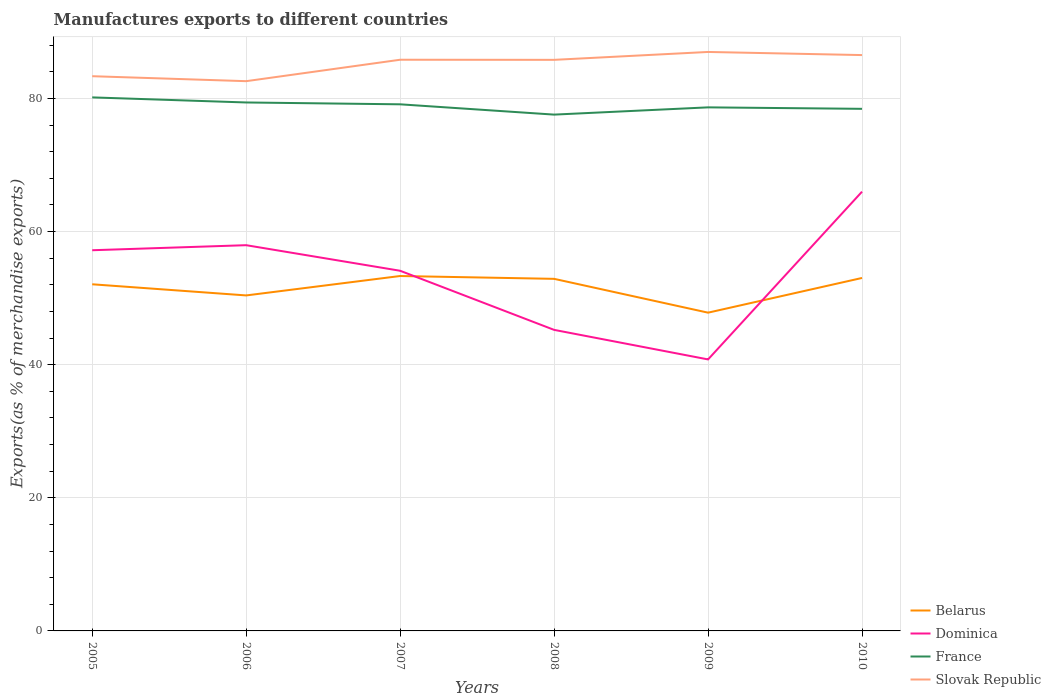How many different coloured lines are there?
Ensure brevity in your answer.  4. Does the line corresponding to Slovak Republic intersect with the line corresponding to Dominica?
Give a very brief answer. No. Across all years, what is the maximum percentage of exports to different countries in France?
Your response must be concise. 77.57. What is the total percentage of exports to different countries in Slovak Republic in the graph?
Your response must be concise. -3.22. What is the difference between the highest and the second highest percentage of exports to different countries in Slovak Republic?
Make the answer very short. 4.39. What is the difference between the highest and the lowest percentage of exports to different countries in Dominica?
Provide a short and direct response. 4. Is the percentage of exports to different countries in Dominica strictly greater than the percentage of exports to different countries in Belarus over the years?
Make the answer very short. No. How many lines are there?
Ensure brevity in your answer.  4. What is the difference between two consecutive major ticks on the Y-axis?
Keep it short and to the point. 20. How many legend labels are there?
Offer a terse response. 4. How are the legend labels stacked?
Your answer should be compact. Vertical. What is the title of the graph?
Make the answer very short. Manufactures exports to different countries. What is the label or title of the Y-axis?
Provide a succinct answer. Exports(as % of merchandise exports). What is the Exports(as % of merchandise exports) of Belarus in 2005?
Provide a succinct answer. 52.08. What is the Exports(as % of merchandise exports) of Dominica in 2005?
Offer a terse response. 57.19. What is the Exports(as % of merchandise exports) of France in 2005?
Provide a short and direct response. 80.15. What is the Exports(as % of merchandise exports) of Slovak Republic in 2005?
Offer a terse response. 83.34. What is the Exports(as % of merchandise exports) of Belarus in 2006?
Your response must be concise. 50.4. What is the Exports(as % of merchandise exports) of Dominica in 2006?
Provide a short and direct response. 57.95. What is the Exports(as % of merchandise exports) of France in 2006?
Keep it short and to the point. 79.39. What is the Exports(as % of merchandise exports) of Slovak Republic in 2006?
Your answer should be very brief. 82.59. What is the Exports(as % of merchandise exports) of Belarus in 2007?
Offer a terse response. 53.32. What is the Exports(as % of merchandise exports) in Dominica in 2007?
Your answer should be compact. 54.11. What is the Exports(as % of merchandise exports) in France in 2007?
Ensure brevity in your answer.  79.11. What is the Exports(as % of merchandise exports) of Slovak Republic in 2007?
Your answer should be very brief. 85.81. What is the Exports(as % of merchandise exports) of Belarus in 2008?
Provide a succinct answer. 52.89. What is the Exports(as % of merchandise exports) in Dominica in 2008?
Provide a short and direct response. 45.23. What is the Exports(as % of merchandise exports) of France in 2008?
Ensure brevity in your answer.  77.57. What is the Exports(as % of merchandise exports) of Slovak Republic in 2008?
Your answer should be very brief. 85.79. What is the Exports(as % of merchandise exports) of Belarus in 2009?
Make the answer very short. 47.81. What is the Exports(as % of merchandise exports) in Dominica in 2009?
Offer a very short reply. 40.79. What is the Exports(as % of merchandise exports) of France in 2009?
Keep it short and to the point. 78.66. What is the Exports(as % of merchandise exports) in Slovak Republic in 2009?
Offer a very short reply. 86.98. What is the Exports(as % of merchandise exports) in Belarus in 2010?
Your answer should be very brief. 53.03. What is the Exports(as % of merchandise exports) in Dominica in 2010?
Give a very brief answer. 65.99. What is the Exports(as % of merchandise exports) of France in 2010?
Provide a succinct answer. 78.44. What is the Exports(as % of merchandise exports) of Slovak Republic in 2010?
Offer a very short reply. 86.51. Across all years, what is the maximum Exports(as % of merchandise exports) of Belarus?
Give a very brief answer. 53.32. Across all years, what is the maximum Exports(as % of merchandise exports) of Dominica?
Give a very brief answer. 65.99. Across all years, what is the maximum Exports(as % of merchandise exports) in France?
Make the answer very short. 80.15. Across all years, what is the maximum Exports(as % of merchandise exports) of Slovak Republic?
Ensure brevity in your answer.  86.98. Across all years, what is the minimum Exports(as % of merchandise exports) of Belarus?
Offer a terse response. 47.81. Across all years, what is the minimum Exports(as % of merchandise exports) of Dominica?
Provide a succinct answer. 40.79. Across all years, what is the minimum Exports(as % of merchandise exports) in France?
Provide a short and direct response. 77.57. Across all years, what is the minimum Exports(as % of merchandise exports) in Slovak Republic?
Keep it short and to the point. 82.59. What is the total Exports(as % of merchandise exports) of Belarus in the graph?
Your answer should be compact. 309.53. What is the total Exports(as % of merchandise exports) in Dominica in the graph?
Make the answer very short. 321.25. What is the total Exports(as % of merchandise exports) in France in the graph?
Your response must be concise. 473.32. What is the total Exports(as % of merchandise exports) of Slovak Republic in the graph?
Your response must be concise. 511.03. What is the difference between the Exports(as % of merchandise exports) in Belarus in 2005 and that in 2006?
Ensure brevity in your answer.  1.67. What is the difference between the Exports(as % of merchandise exports) of Dominica in 2005 and that in 2006?
Offer a very short reply. -0.76. What is the difference between the Exports(as % of merchandise exports) in France in 2005 and that in 2006?
Give a very brief answer. 0.76. What is the difference between the Exports(as % of merchandise exports) in Slovak Republic in 2005 and that in 2006?
Make the answer very short. 0.75. What is the difference between the Exports(as % of merchandise exports) in Belarus in 2005 and that in 2007?
Your answer should be compact. -1.24. What is the difference between the Exports(as % of merchandise exports) of Dominica in 2005 and that in 2007?
Make the answer very short. 3.08. What is the difference between the Exports(as % of merchandise exports) in France in 2005 and that in 2007?
Make the answer very short. 1.04. What is the difference between the Exports(as % of merchandise exports) in Slovak Republic in 2005 and that in 2007?
Provide a short and direct response. -2.47. What is the difference between the Exports(as % of merchandise exports) of Belarus in 2005 and that in 2008?
Offer a very short reply. -0.82. What is the difference between the Exports(as % of merchandise exports) in Dominica in 2005 and that in 2008?
Provide a short and direct response. 11.96. What is the difference between the Exports(as % of merchandise exports) in France in 2005 and that in 2008?
Give a very brief answer. 2.59. What is the difference between the Exports(as % of merchandise exports) in Slovak Republic in 2005 and that in 2008?
Provide a short and direct response. -2.46. What is the difference between the Exports(as % of merchandise exports) in Belarus in 2005 and that in 2009?
Provide a succinct answer. 4.26. What is the difference between the Exports(as % of merchandise exports) of Dominica in 2005 and that in 2009?
Your response must be concise. 16.4. What is the difference between the Exports(as % of merchandise exports) of France in 2005 and that in 2009?
Keep it short and to the point. 1.5. What is the difference between the Exports(as % of merchandise exports) in Slovak Republic in 2005 and that in 2009?
Your answer should be very brief. -3.64. What is the difference between the Exports(as % of merchandise exports) in Belarus in 2005 and that in 2010?
Provide a succinct answer. -0.95. What is the difference between the Exports(as % of merchandise exports) in Dominica in 2005 and that in 2010?
Make the answer very short. -8.8. What is the difference between the Exports(as % of merchandise exports) in France in 2005 and that in 2010?
Offer a very short reply. 1.72. What is the difference between the Exports(as % of merchandise exports) of Slovak Republic in 2005 and that in 2010?
Your answer should be very brief. -3.17. What is the difference between the Exports(as % of merchandise exports) of Belarus in 2006 and that in 2007?
Your response must be concise. -2.92. What is the difference between the Exports(as % of merchandise exports) of Dominica in 2006 and that in 2007?
Offer a terse response. 3.84. What is the difference between the Exports(as % of merchandise exports) in France in 2006 and that in 2007?
Ensure brevity in your answer.  0.28. What is the difference between the Exports(as % of merchandise exports) in Slovak Republic in 2006 and that in 2007?
Keep it short and to the point. -3.22. What is the difference between the Exports(as % of merchandise exports) of Belarus in 2006 and that in 2008?
Make the answer very short. -2.49. What is the difference between the Exports(as % of merchandise exports) of Dominica in 2006 and that in 2008?
Your answer should be very brief. 12.72. What is the difference between the Exports(as % of merchandise exports) of France in 2006 and that in 2008?
Your response must be concise. 1.82. What is the difference between the Exports(as % of merchandise exports) in Slovak Republic in 2006 and that in 2008?
Give a very brief answer. -3.2. What is the difference between the Exports(as % of merchandise exports) in Belarus in 2006 and that in 2009?
Keep it short and to the point. 2.59. What is the difference between the Exports(as % of merchandise exports) of Dominica in 2006 and that in 2009?
Provide a short and direct response. 17.16. What is the difference between the Exports(as % of merchandise exports) in France in 2006 and that in 2009?
Give a very brief answer. 0.73. What is the difference between the Exports(as % of merchandise exports) in Slovak Republic in 2006 and that in 2009?
Offer a terse response. -4.39. What is the difference between the Exports(as % of merchandise exports) in Belarus in 2006 and that in 2010?
Your response must be concise. -2.62. What is the difference between the Exports(as % of merchandise exports) of Dominica in 2006 and that in 2010?
Offer a very short reply. -8.04. What is the difference between the Exports(as % of merchandise exports) in France in 2006 and that in 2010?
Ensure brevity in your answer.  0.96. What is the difference between the Exports(as % of merchandise exports) of Slovak Republic in 2006 and that in 2010?
Give a very brief answer. -3.92. What is the difference between the Exports(as % of merchandise exports) of Belarus in 2007 and that in 2008?
Your answer should be very brief. 0.43. What is the difference between the Exports(as % of merchandise exports) of Dominica in 2007 and that in 2008?
Offer a terse response. 8.88. What is the difference between the Exports(as % of merchandise exports) in France in 2007 and that in 2008?
Provide a succinct answer. 1.55. What is the difference between the Exports(as % of merchandise exports) in Slovak Republic in 2007 and that in 2008?
Provide a short and direct response. 0.02. What is the difference between the Exports(as % of merchandise exports) of Belarus in 2007 and that in 2009?
Your answer should be very brief. 5.51. What is the difference between the Exports(as % of merchandise exports) in Dominica in 2007 and that in 2009?
Provide a succinct answer. 13.32. What is the difference between the Exports(as % of merchandise exports) in France in 2007 and that in 2009?
Give a very brief answer. 0.46. What is the difference between the Exports(as % of merchandise exports) in Slovak Republic in 2007 and that in 2009?
Your response must be concise. -1.17. What is the difference between the Exports(as % of merchandise exports) in Belarus in 2007 and that in 2010?
Your response must be concise. 0.29. What is the difference between the Exports(as % of merchandise exports) of Dominica in 2007 and that in 2010?
Provide a succinct answer. -11.88. What is the difference between the Exports(as % of merchandise exports) of France in 2007 and that in 2010?
Keep it short and to the point. 0.68. What is the difference between the Exports(as % of merchandise exports) of Slovak Republic in 2007 and that in 2010?
Ensure brevity in your answer.  -0.7. What is the difference between the Exports(as % of merchandise exports) of Belarus in 2008 and that in 2009?
Your response must be concise. 5.08. What is the difference between the Exports(as % of merchandise exports) of Dominica in 2008 and that in 2009?
Offer a terse response. 4.44. What is the difference between the Exports(as % of merchandise exports) in France in 2008 and that in 2009?
Your answer should be compact. -1.09. What is the difference between the Exports(as % of merchandise exports) of Slovak Republic in 2008 and that in 2009?
Your answer should be compact. -1.19. What is the difference between the Exports(as % of merchandise exports) in Belarus in 2008 and that in 2010?
Your answer should be very brief. -0.13. What is the difference between the Exports(as % of merchandise exports) in Dominica in 2008 and that in 2010?
Your answer should be compact. -20.76. What is the difference between the Exports(as % of merchandise exports) of France in 2008 and that in 2010?
Offer a very short reply. -0.87. What is the difference between the Exports(as % of merchandise exports) in Slovak Republic in 2008 and that in 2010?
Ensure brevity in your answer.  -0.72. What is the difference between the Exports(as % of merchandise exports) in Belarus in 2009 and that in 2010?
Make the answer very short. -5.21. What is the difference between the Exports(as % of merchandise exports) in Dominica in 2009 and that in 2010?
Give a very brief answer. -25.2. What is the difference between the Exports(as % of merchandise exports) of France in 2009 and that in 2010?
Your answer should be very brief. 0.22. What is the difference between the Exports(as % of merchandise exports) of Slovak Republic in 2009 and that in 2010?
Ensure brevity in your answer.  0.47. What is the difference between the Exports(as % of merchandise exports) of Belarus in 2005 and the Exports(as % of merchandise exports) of Dominica in 2006?
Provide a short and direct response. -5.87. What is the difference between the Exports(as % of merchandise exports) of Belarus in 2005 and the Exports(as % of merchandise exports) of France in 2006?
Your answer should be very brief. -27.31. What is the difference between the Exports(as % of merchandise exports) in Belarus in 2005 and the Exports(as % of merchandise exports) in Slovak Republic in 2006?
Provide a succinct answer. -30.51. What is the difference between the Exports(as % of merchandise exports) in Dominica in 2005 and the Exports(as % of merchandise exports) in France in 2006?
Provide a short and direct response. -22.2. What is the difference between the Exports(as % of merchandise exports) of Dominica in 2005 and the Exports(as % of merchandise exports) of Slovak Republic in 2006?
Provide a short and direct response. -25.4. What is the difference between the Exports(as % of merchandise exports) in France in 2005 and the Exports(as % of merchandise exports) in Slovak Republic in 2006?
Offer a very short reply. -2.44. What is the difference between the Exports(as % of merchandise exports) of Belarus in 2005 and the Exports(as % of merchandise exports) of Dominica in 2007?
Ensure brevity in your answer.  -2.03. What is the difference between the Exports(as % of merchandise exports) of Belarus in 2005 and the Exports(as % of merchandise exports) of France in 2007?
Offer a very short reply. -27.04. What is the difference between the Exports(as % of merchandise exports) in Belarus in 2005 and the Exports(as % of merchandise exports) in Slovak Republic in 2007?
Keep it short and to the point. -33.73. What is the difference between the Exports(as % of merchandise exports) in Dominica in 2005 and the Exports(as % of merchandise exports) in France in 2007?
Make the answer very short. -21.92. What is the difference between the Exports(as % of merchandise exports) of Dominica in 2005 and the Exports(as % of merchandise exports) of Slovak Republic in 2007?
Provide a succinct answer. -28.62. What is the difference between the Exports(as % of merchandise exports) in France in 2005 and the Exports(as % of merchandise exports) in Slovak Republic in 2007?
Your response must be concise. -5.66. What is the difference between the Exports(as % of merchandise exports) of Belarus in 2005 and the Exports(as % of merchandise exports) of Dominica in 2008?
Offer a very short reply. 6.85. What is the difference between the Exports(as % of merchandise exports) of Belarus in 2005 and the Exports(as % of merchandise exports) of France in 2008?
Offer a very short reply. -25.49. What is the difference between the Exports(as % of merchandise exports) of Belarus in 2005 and the Exports(as % of merchandise exports) of Slovak Republic in 2008?
Your answer should be compact. -33.72. What is the difference between the Exports(as % of merchandise exports) in Dominica in 2005 and the Exports(as % of merchandise exports) in France in 2008?
Your answer should be compact. -20.38. What is the difference between the Exports(as % of merchandise exports) of Dominica in 2005 and the Exports(as % of merchandise exports) of Slovak Republic in 2008?
Your response must be concise. -28.6. What is the difference between the Exports(as % of merchandise exports) of France in 2005 and the Exports(as % of merchandise exports) of Slovak Republic in 2008?
Give a very brief answer. -5.64. What is the difference between the Exports(as % of merchandise exports) in Belarus in 2005 and the Exports(as % of merchandise exports) in Dominica in 2009?
Keep it short and to the point. 11.29. What is the difference between the Exports(as % of merchandise exports) of Belarus in 2005 and the Exports(as % of merchandise exports) of France in 2009?
Offer a terse response. -26.58. What is the difference between the Exports(as % of merchandise exports) of Belarus in 2005 and the Exports(as % of merchandise exports) of Slovak Republic in 2009?
Your response must be concise. -34.9. What is the difference between the Exports(as % of merchandise exports) in Dominica in 2005 and the Exports(as % of merchandise exports) in France in 2009?
Ensure brevity in your answer.  -21.47. What is the difference between the Exports(as % of merchandise exports) of Dominica in 2005 and the Exports(as % of merchandise exports) of Slovak Republic in 2009?
Ensure brevity in your answer.  -29.79. What is the difference between the Exports(as % of merchandise exports) of France in 2005 and the Exports(as % of merchandise exports) of Slovak Republic in 2009?
Make the answer very short. -6.83. What is the difference between the Exports(as % of merchandise exports) in Belarus in 2005 and the Exports(as % of merchandise exports) in Dominica in 2010?
Give a very brief answer. -13.91. What is the difference between the Exports(as % of merchandise exports) of Belarus in 2005 and the Exports(as % of merchandise exports) of France in 2010?
Your answer should be very brief. -26.36. What is the difference between the Exports(as % of merchandise exports) of Belarus in 2005 and the Exports(as % of merchandise exports) of Slovak Republic in 2010?
Offer a terse response. -34.43. What is the difference between the Exports(as % of merchandise exports) in Dominica in 2005 and the Exports(as % of merchandise exports) in France in 2010?
Offer a terse response. -21.24. What is the difference between the Exports(as % of merchandise exports) in Dominica in 2005 and the Exports(as % of merchandise exports) in Slovak Republic in 2010?
Provide a succinct answer. -29.32. What is the difference between the Exports(as % of merchandise exports) in France in 2005 and the Exports(as % of merchandise exports) in Slovak Republic in 2010?
Keep it short and to the point. -6.36. What is the difference between the Exports(as % of merchandise exports) in Belarus in 2006 and the Exports(as % of merchandise exports) in Dominica in 2007?
Offer a very short reply. -3.7. What is the difference between the Exports(as % of merchandise exports) of Belarus in 2006 and the Exports(as % of merchandise exports) of France in 2007?
Your answer should be compact. -28.71. What is the difference between the Exports(as % of merchandise exports) of Belarus in 2006 and the Exports(as % of merchandise exports) of Slovak Republic in 2007?
Offer a very short reply. -35.41. What is the difference between the Exports(as % of merchandise exports) in Dominica in 2006 and the Exports(as % of merchandise exports) in France in 2007?
Offer a terse response. -21.16. What is the difference between the Exports(as % of merchandise exports) of Dominica in 2006 and the Exports(as % of merchandise exports) of Slovak Republic in 2007?
Keep it short and to the point. -27.86. What is the difference between the Exports(as % of merchandise exports) of France in 2006 and the Exports(as % of merchandise exports) of Slovak Republic in 2007?
Give a very brief answer. -6.42. What is the difference between the Exports(as % of merchandise exports) in Belarus in 2006 and the Exports(as % of merchandise exports) in Dominica in 2008?
Give a very brief answer. 5.17. What is the difference between the Exports(as % of merchandise exports) of Belarus in 2006 and the Exports(as % of merchandise exports) of France in 2008?
Keep it short and to the point. -27.16. What is the difference between the Exports(as % of merchandise exports) in Belarus in 2006 and the Exports(as % of merchandise exports) in Slovak Republic in 2008?
Your answer should be very brief. -35.39. What is the difference between the Exports(as % of merchandise exports) of Dominica in 2006 and the Exports(as % of merchandise exports) of France in 2008?
Provide a short and direct response. -19.62. What is the difference between the Exports(as % of merchandise exports) in Dominica in 2006 and the Exports(as % of merchandise exports) in Slovak Republic in 2008?
Make the answer very short. -27.84. What is the difference between the Exports(as % of merchandise exports) in France in 2006 and the Exports(as % of merchandise exports) in Slovak Republic in 2008?
Make the answer very short. -6.4. What is the difference between the Exports(as % of merchandise exports) of Belarus in 2006 and the Exports(as % of merchandise exports) of Dominica in 2009?
Ensure brevity in your answer.  9.61. What is the difference between the Exports(as % of merchandise exports) of Belarus in 2006 and the Exports(as % of merchandise exports) of France in 2009?
Offer a very short reply. -28.25. What is the difference between the Exports(as % of merchandise exports) in Belarus in 2006 and the Exports(as % of merchandise exports) in Slovak Republic in 2009?
Offer a terse response. -36.58. What is the difference between the Exports(as % of merchandise exports) of Dominica in 2006 and the Exports(as % of merchandise exports) of France in 2009?
Make the answer very short. -20.71. What is the difference between the Exports(as % of merchandise exports) in Dominica in 2006 and the Exports(as % of merchandise exports) in Slovak Republic in 2009?
Offer a terse response. -29.03. What is the difference between the Exports(as % of merchandise exports) in France in 2006 and the Exports(as % of merchandise exports) in Slovak Republic in 2009?
Your answer should be compact. -7.59. What is the difference between the Exports(as % of merchandise exports) of Belarus in 2006 and the Exports(as % of merchandise exports) of Dominica in 2010?
Provide a succinct answer. -15.59. What is the difference between the Exports(as % of merchandise exports) in Belarus in 2006 and the Exports(as % of merchandise exports) in France in 2010?
Provide a short and direct response. -28.03. What is the difference between the Exports(as % of merchandise exports) of Belarus in 2006 and the Exports(as % of merchandise exports) of Slovak Republic in 2010?
Offer a terse response. -36.11. What is the difference between the Exports(as % of merchandise exports) of Dominica in 2006 and the Exports(as % of merchandise exports) of France in 2010?
Your answer should be compact. -20.49. What is the difference between the Exports(as % of merchandise exports) in Dominica in 2006 and the Exports(as % of merchandise exports) in Slovak Republic in 2010?
Provide a succinct answer. -28.56. What is the difference between the Exports(as % of merchandise exports) of France in 2006 and the Exports(as % of merchandise exports) of Slovak Republic in 2010?
Provide a short and direct response. -7.12. What is the difference between the Exports(as % of merchandise exports) in Belarus in 2007 and the Exports(as % of merchandise exports) in Dominica in 2008?
Your answer should be compact. 8.09. What is the difference between the Exports(as % of merchandise exports) of Belarus in 2007 and the Exports(as % of merchandise exports) of France in 2008?
Provide a short and direct response. -24.25. What is the difference between the Exports(as % of merchandise exports) of Belarus in 2007 and the Exports(as % of merchandise exports) of Slovak Republic in 2008?
Your response must be concise. -32.47. What is the difference between the Exports(as % of merchandise exports) of Dominica in 2007 and the Exports(as % of merchandise exports) of France in 2008?
Offer a terse response. -23.46. What is the difference between the Exports(as % of merchandise exports) in Dominica in 2007 and the Exports(as % of merchandise exports) in Slovak Republic in 2008?
Give a very brief answer. -31.69. What is the difference between the Exports(as % of merchandise exports) of France in 2007 and the Exports(as % of merchandise exports) of Slovak Republic in 2008?
Provide a succinct answer. -6.68. What is the difference between the Exports(as % of merchandise exports) of Belarus in 2007 and the Exports(as % of merchandise exports) of Dominica in 2009?
Keep it short and to the point. 12.53. What is the difference between the Exports(as % of merchandise exports) in Belarus in 2007 and the Exports(as % of merchandise exports) in France in 2009?
Offer a very short reply. -25.34. What is the difference between the Exports(as % of merchandise exports) of Belarus in 2007 and the Exports(as % of merchandise exports) of Slovak Republic in 2009?
Your response must be concise. -33.66. What is the difference between the Exports(as % of merchandise exports) in Dominica in 2007 and the Exports(as % of merchandise exports) in France in 2009?
Give a very brief answer. -24.55. What is the difference between the Exports(as % of merchandise exports) in Dominica in 2007 and the Exports(as % of merchandise exports) in Slovak Republic in 2009?
Offer a terse response. -32.87. What is the difference between the Exports(as % of merchandise exports) in France in 2007 and the Exports(as % of merchandise exports) in Slovak Republic in 2009?
Your answer should be very brief. -7.87. What is the difference between the Exports(as % of merchandise exports) in Belarus in 2007 and the Exports(as % of merchandise exports) in Dominica in 2010?
Make the answer very short. -12.67. What is the difference between the Exports(as % of merchandise exports) of Belarus in 2007 and the Exports(as % of merchandise exports) of France in 2010?
Your response must be concise. -25.12. What is the difference between the Exports(as % of merchandise exports) in Belarus in 2007 and the Exports(as % of merchandise exports) in Slovak Republic in 2010?
Provide a succinct answer. -33.19. What is the difference between the Exports(as % of merchandise exports) in Dominica in 2007 and the Exports(as % of merchandise exports) in France in 2010?
Your response must be concise. -24.33. What is the difference between the Exports(as % of merchandise exports) of Dominica in 2007 and the Exports(as % of merchandise exports) of Slovak Republic in 2010?
Make the answer very short. -32.4. What is the difference between the Exports(as % of merchandise exports) in France in 2007 and the Exports(as % of merchandise exports) in Slovak Republic in 2010?
Your response must be concise. -7.4. What is the difference between the Exports(as % of merchandise exports) of Belarus in 2008 and the Exports(as % of merchandise exports) of Dominica in 2009?
Provide a short and direct response. 12.11. What is the difference between the Exports(as % of merchandise exports) in Belarus in 2008 and the Exports(as % of merchandise exports) in France in 2009?
Offer a very short reply. -25.76. What is the difference between the Exports(as % of merchandise exports) of Belarus in 2008 and the Exports(as % of merchandise exports) of Slovak Republic in 2009?
Ensure brevity in your answer.  -34.09. What is the difference between the Exports(as % of merchandise exports) in Dominica in 2008 and the Exports(as % of merchandise exports) in France in 2009?
Your answer should be very brief. -33.43. What is the difference between the Exports(as % of merchandise exports) in Dominica in 2008 and the Exports(as % of merchandise exports) in Slovak Republic in 2009?
Provide a short and direct response. -41.75. What is the difference between the Exports(as % of merchandise exports) in France in 2008 and the Exports(as % of merchandise exports) in Slovak Republic in 2009?
Provide a succinct answer. -9.41. What is the difference between the Exports(as % of merchandise exports) in Belarus in 2008 and the Exports(as % of merchandise exports) in Dominica in 2010?
Your answer should be very brief. -13.1. What is the difference between the Exports(as % of merchandise exports) in Belarus in 2008 and the Exports(as % of merchandise exports) in France in 2010?
Provide a short and direct response. -25.54. What is the difference between the Exports(as % of merchandise exports) of Belarus in 2008 and the Exports(as % of merchandise exports) of Slovak Republic in 2010?
Give a very brief answer. -33.62. What is the difference between the Exports(as % of merchandise exports) of Dominica in 2008 and the Exports(as % of merchandise exports) of France in 2010?
Provide a succinct answer. -33.21. What is the difference between the Exports(as % of merchandise exports) in Dominica in 2008 and the Exports(as % of merchandise exports) in Slovak Republic in 2010?
Provide a short and direct response. -41.28. What is the difference between the Exports(as % of merchandise exports) of France in 2008 and the Exports(as % of merchandise exports) of Slovak Republic in 2010?
Offer a very short reply. -8.94. What is the difference between the Exports(as % of merchandise exports) of Belarus in 2009 and the Exports(as % of merchandise exports) of Dominica in 2010?
Offer a very short reply. -18.18. What is the difference between the Exports(as % of merchandise exports) in Belarus in 2009 and the Exports(as % of merchandise exports) in France in 2010?
Keep it short and to the point. -30.62. What is the difference between the Exports(as % of merchandise exports) of Belarus in 2009 and the Exports(as % of merchandise exports) of Slovak Republic in 2010?
Give a very brief answer. -38.7. What is the difference between the Exports(as % of merchandise exports) of Dominica in 2009 and the Exports(as % of merchandise exports) of France in 2010?
Make the answer very short. -37.65. What is the difference between the Exports(as % of merchandise exports) in Dominica in 2009 and the Exports(as % of merchandise exports) in Slovak Republic in 2010?
Provide a short and direct response. -45.72. What is the difference between the Exports(as % of merchandise exports) of France in 2009 and the Exports(as % of merchandise exports) of Slovak Republic in 2010?
Provide a succinct answer. -7.85. What is the average Exports(as % of merchandise exports) in Belarus per year?
Your answer should be compact. 51.59. What is the average Exports(as % of merchandise exports) of Dominica per year?
Ensure brevity in your answer.  53.54. What is the average Exports(as % of merchandise exports) of France per year?
Offer a terse response. 78.89. What is the average Exports(as % of merchandise exports) in Slovak Republic per year?
Make the answer very short. 85.17. In the year 2005, what is the difference between the Exports(as % of merchandise exports) of Belarus and Exports(as % of merchandise exports) of Dominica?
Make the answer very short. -5.11. In the year 2005, what is the difference between the Exports(as % of merchandise exports) in Belarus and Exports(as % of merchandise exports) in France?
Your response must be concise. -28.08. In the year 2005, what is the difference between the Exports(as % of merchandise exports) of Belarus and Exports(as % of merchandise exports) of Slovak Republic?
Your answer should be compact. -31.26. In the year 2005, what is the difference between the Exports(as % of merchandise exports) of Dominica and Exports(as % of merchandise exports) of France?
Offer a terse response. -22.96. In the year 2005, what is the difference between the Exports(as % of merchandise exports) of Dominica and Exports(as % of merchandise exports) of Slovak Republic?
Give a very brief answer. -26.15. In the year 2005, what is the difference between the Exports(as % of merchandise exports) of France and Exports(as % of merchandise exports) of Slovak Republic?
Offer a terse response. -3.18. In the year 2006, what is the difference between the Exports(as % of merchandise exports) in Belarus and Exports(as % of merchandise exports) in Dominica?
Make the answer very short. -7.55. In the year 2006, what is the difference between the Exports(as % of merchandise exports) in Belarus and Exports(as % of merchandise exports) in France?
Keep it short and to the point. -28.99. In the year 2006, what is the difference between the Exports(as % of merchandise exports) in Belarus and Exports(as % of merchandise exports) in Slovak Republic?
Give a very brief answer. -32.19. In the year 2006, what is the difference between the Exports(as % of merchandise exports) of Dominica and Exports(as % of merchandise exports) of France?
Provide a succinct answer. -21.44. In the year 2006, what is the difference between the Exports(as % of merchandise exports) in Dominica and Exports(as % of merchandise exports) in Slovak Republic?
Provide a succinct answer. -24.64. In the year 2006, what is the difference between the Exports(as % of merchandise exports) of France and Exports(as % of merchandise exports) of Slovak Republic?
Give a very brief answer. -3.2. In the year 2007, what is the difference between the Exports(as % of merchandise exports) in Belarus and Exports(as % of merchandise exports) in Dominica?
Keep it short and to the point. -0.79. In the year 2007, what is the difference between the Exports(as % of merchandise exports) in Belarus and Exports(as % of merchandise exports) in France?
Make the answer very short. -25.79. In the year 2007, what is the difference between the Exports(as % of merchandise exports) in Belarus and Exports(as % of merchandise exports) in Slovak Republic?
Your answer should be very brief. -32.49. In the year 2007, what is the difference between the Exports(as % of merchandise exports) of Dominica and Exports(as % of merchandise exports) of France?
Make the answer very short. -25.01. In the year 2007, what is the difference between the Exports(as % of merchandise exports) of Dominica and Exports(as % of merchandise exports) of Slovak Republic?
Your answer should be very brief. -31.7. In the year 2007, what is the difference between the Exports(as % of merchandise exports) in France and Exports(as % of merchandise exports) in Slovak Republic?
Ensure brevity in your answer.  -6.7. In the year 2008, what is the difference between the Exports(as % of merchandise exports) in Belarus and Exports(as % of merchandise exports) in Dominica?
Keep it short and to the point. 7.67. In the year 2008, what is the difference between the Exports(as % of merchandise exports) in Belarus and Exports(as % of merchandise exports) in France?
Give a very brief answer. -24.67. In the year 2008, what is the difference between the Exports(as % of merchandise exports) of Belarus and Exports(as % of merchandise exports) of Slovak Republic?
Ensure brevity in your answer.  -32.9. In the year 2008, what is the difference between the Exports(as % of merchandise exports) of Dominica and Exports(as % of merchandise exports) of France?
Ensure brevity in your answer.  -32.34. In the year 2008, what is the difference between the Exports(as % of merchandise exports) in Dominica and Exports(as % of merchandise exports) in Slovak Republic?
Your answer should be very brief. -40.57. In the year 2008, what is the difference between the Exports(as % of merchandise exports) in France and Exports(as % of merchandise exports) in Slovak Republic?
Offer a very short reply. -8.23. In the year 2009, what is the difference between the Exports(as % of merchandise exports) of Belarus and Exports(as % of merchandise exports) of Dominica?
Ensure brevity in your answer.  7.03. In the year 2009, what is the difference between the Exports(as % of merchandise exports) in Belarus and Exports(as % of merchandise exports) in France?
Provide a short and direct response. -30.84. In the year 2009, what is the difference between the Exports(as % of merchandise exports) of Belarus and Exports(as % of merchandise exports) of Slovak Republic?
Provide a short and direct response. -39.17. In the year 2009, what is the difference between the Exports(as % of merchandise exports) in Dominica and Exports(as % of merchandise exports) in France?
Give a very brief answer. -37.87. In the year 2009, what is the difference between the Exports(as % of merchandise exports) in Dominica and Exports(as % of merchandise exports) in Slovak Republic?
Offer a terse response. -46.19. In the year 2009, what is the difference between the Exports(as % of merchandise exports) of France and Exports(as % of merchandise exports) of Slovak Republic?
Offer a terse response. -8.32. In the year 2010, what is the difference between the Exports(as % of merchandise exports) in Belarus and Exports(as % of merchandise exports) in Dominica?
Give a very brief answer. -12.96. In the year 2010, what is the difference between the Exports(as % of merchandise exports) of Belarus and Exports(as % of merchandise exports) of France?
Provide a succinct answer. -25.41. In the year 2010, what is the difference between the Exports(as % of merchandise exports) of Belarus and Exports(as % of merchandise exports) of Slovak Republic?
Provide a succinct answer. -33.48. In the year 2010, what is the difference between the Exports(as % of merchandise exports) of Dominica and Exports(as % of merchandise exports) of France?
Make the answer very short. -12.45. In the year 2010, what is the difference between the Exports(as % of merchandise exports) of Dominica and Exports(as % of merchandise exports) of Slovak Republic?
Offer a very short reply. -20.52. In the year 2010, what is the difference between the Exports(as % of merchandise exports) of France and Exports(as % of merchandise exports) of Slovak Republic?
Keep it short and to the point. -8.08. What is the ratio of the Exports(as % of merchandise exports) in Belarus in 2005 to that in 2006?
Your response must be concise. 1.03. What is the ratio of the Exports(as % of merchandise exports) of Dominica in 2005 to that in 2006?
Give a very brief answer. 0.99. What is the ratio of the Exports(as % of merchandise exports) of France in 2005 to that in 2006?
Your answer should be compact. 1.01. What is the ratio of the Exports(as % of merchandise exports) in Slovak Republic in 2005 to that in 2006?
Your response must be concise. 1.01. What is the ratio of the Exports(as % of merchandise exports) in Belarus in 2005 to that in 2007?
Your answer should be compact. 0.98. What is the ratio of the Exports(as % of merchandise exports) of Dominica in 2005 to that in 2007?
Give a very brief answer. 1.06. What is the ratio of the Exports(as % of merchandise exports) of France in 2005 to that in 2007?
Keep it short and to the point. 1.01. What is the ratio of the Exports(as % of merchandise exports) of Slovak Republic in 2005 to that in 2007?
Your answer should be compact. 0.97. What is the ratio of the Exports(as % of merchandise exports) in Belarus in 2005 to that in 2008?
Ensure brevity in your answer.  0.98. What is the ratio of the Exports(as % of merchandise exports) of Dominica in 2005 to that in 2008?
Your answer should be compact. 1.26. What is the ratio of the Exports(as % of merchandise exports) in Slovak Republic in 2005 to that in 2008?
Offer a very short reply. 0.97. What is the ratio of the Exports(as % of merchandise exports) in Belarus in 2005 to that in 2009?
Your answer should be compact. 1.09. What is the ratio of the Exports(as % of merchandise exports) in Dominica in 2005 to that in 2009?
Provide a succinct answer. 1.4. What is the ratio of the Exports(as % of merchandise exports) in Slovak Republic in 2005 to that in 2009?
Your answer should be very brief. 0.96. What is the ratio of the Exports(as % of merchandise exports) of Belarus in 2005 to that in 2010?
Provide a succinct answer. 0.98. What is the ratio of the Exports(as % of merchandise exports) of Dominica in 2005 to that in 2010?
Make the answer very short. 0.87. What is the ratio of the Exports(as % of merchandise exports) in France in 2005 to that in 2010?
Your response must be concise. 1.02. What is the ratio of the Exports(as % of merchandise exports) in Slovak Republic in 2005 to that in 2010?
Keep it short and to the point. 0.96. What is the ratio of the Exports(as % of merchandise exports) of Belarus in 2006 to that in 2007?
Provide a succinct answer. 0.95. What is the ratio of the Exports(as % of merchandise exports) of Dominica in 2006 to that in 2007?
Offer a terse response. 1.07. What is the ratio of the Exports(as % of merchandise exports) of France in 2006 to that in 2007?
Ensure brevity in your answer.  1. What is the ratio of the Exports(as % of merchandise exports) in Slovak Republic in 2006 to that in 2007?
Provide a short and direct response. 0.96. What is the ratio of the Exports(as % of merchandise exports) of Belarus in 2006 to that in 2008?
Provide a succinct answer. 0.95. What is the ratio of the Exports(as % of merchandise exports) of Dominica in 2006 to that in 2008?
Keep it short and to the point. 1.28. What is the ratio of the Exports(as % of merchandise exports) of France in 2006 to that in 2008?
Give a very brief answer. 1.02. What is the ratio of the Exports(as % of merchandise exports) of Slovak Republic in 2006 to that in 2008?
Make the answer very short. 0.96. What is the ratio of the Exports(as % of merchandise exports) in Belarus in 2006 to that in 2009?
Keep it short and to the point. 1.05. What is the ratio of the Exports(as % of merchandise exports) in Dominica in 2006 to that in 2009?
Your answer should be compact. 1.42. What is the ratio of the Exports(as % of merchandise exports) in France in 2006 to that in 2009?
Your answer should be very brief. 1.01. What is the ratio of the Exports(as % of merchandise exports) of Slovak Republic in 2006 to that in 2009?
Ensure brevity in your answer.  0.95. What is the ratio of the Exports(as % of merchandise exports) in Belarus in 2006 to that in 2010?
Offer a very short reply. 0.95. What is the ratio of the Exports(as % of merchandise exports) of Dominica in 2006 to that in 2010?
Ensure brevity in your answer.  0.88. What is the ratio of the Exports(as % of merchandise exports) in France in 2006 to that in 2010?
Your answer should be very brief. 1.01. What is the ratio of the Exports(as % of merchandise exports) of Slovak Republic in 2006 to that in 2010?
Give a very brief answer. 0.95. What is the ratio of the Exports(as % of merchandise exports) in Dominica in 2007 to that in 2008?
Your response must be concise. 1.2. What is the ratio of the Exports(as % of merchandise exports) in France in 2007 to that in 2008?
Provide a succinct answer. 1.02. What is the ratio of the Exports(as % of merchandise exports) in Belarus in 2007 to that in 2009?
Provide a short and direct response. 1.12. What is the ratio of the Exports(as % of merchandise exports) in Dominica in 2007 to that in 2009?
Keep it short and to the point. 1.33. What is the ratio of the Exports(as % of merchandise exports) in Slovak Republic in 2007 to that in 2009?
Ensure brevity in your answer.  0.99. What is the ratio of the Exports(as % of merchandise exports) in Dominica in 2007 to that in 2010?
Keep it short and to the point. 0.82. What is the ratio of the Exports(as % of merchandise exports) of France in 2007 to that in 2010?
Ensure brevity in your answer.  1.01. What is the ratio of the Exports(as % of merchandise exports) in Slovak Republic in 2007 to that in 2010?
Provide a short and direct response. 0.99. What is the ratio of the Exports(as % of merchandise exports) of Belarus in 2008 to that in 2009?
Give a very brief answer. 1.11. What is the ratio of the Exports(as % of merchandise exports) of Dominica in 2008 to that in 2009?
Your answer should be very brief. 1.11. What is the ratio of the Exports(as % of merchandise exports) of France in 2008 to that in 2009?
Keep it short and to the point. 0.99. What is the ratio of the Exports(as % of merchandise exports) of Slovak Republic in 2008 to that in 2009?
Make the answer very short. 0.99. What is the ratio of the Exports(as % of merchandise exports) in Belarus in 2008 to that in 2010?
Your response must be concise. 1. What is the ratio of the Exports(as % of merchandise exports) of Dominica in 2008 to that in 2010?
Provide a succinct answer. 0.69. What is the ratio of the Exports(as % of merchandise exports) in France in 2008 to that in 2010?
Provide a succinct answer. 0.99. What is the ratio of the Exports(as % of merchandise exports) in Slovak Republic in 2008 to that in 2010?
Offer a terse response. 0.99. What is the ratio of the Exports(as % of merchandise exports) in Belarus in 2009 to that in 2010?
Provide a succinct answer. 0.9. What is the ratio of the Exports(as % of merchandise exports) in Dominica in 2009 to that in 2010?
Offer a very short reply. 0.62. What is the ratio of the Exports(as % of merchandise exports) of France in 2009 to that in 2010?
Offer a terse response. 1. What is the ratio of the Exports(as % of merchandise exports) in Slovak Republic in 2009 to that in 2010?
Give a very brief answer. 1.01. What is the difference between the highest and the second highest Exports(as % of merchandise exports) of Belarus?
Keep it short and to the point. 0.29. What is the difference between the highest and the second highest Exports(as % of merchandise exports) of Dominica?
Offer a very short reply. 8.04. What is the difference between the highest and the second highest Exports(as % of merchandise exports) of France?
Your answer should be very brief. 0.76. What is the difference between the highest and the second highest Exports(as % of merchandise exports) of Slovak Republic?
Keep it short and to the point. 0.47. What is the difference between the highest and the lowest Exports(as % of merchandise exports) in Belarus?
Give a very brief answer. 5.51. What is the difference between the highest and the lowest Exports(as % of merchandise exports) in Dominica?
Your response must be concise. 25.2. What is the difference between the highest and the lowest Exports(as % of merchandise exports) of France?
Offer a very short reply. 2.59. What is the difference between the highest and the lowest Exports(as % of merchandise exports) in Slovak Republic?
Give a very brief answer. 4.39. 